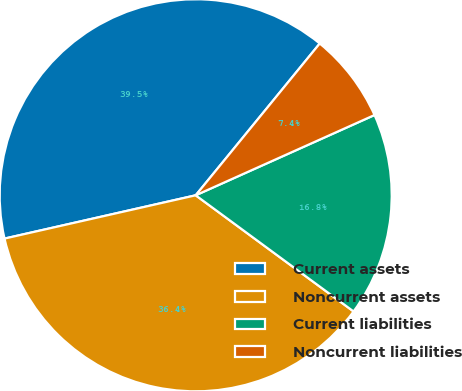Convert chart. <chart><loc_0><loc_0><loc_500><loc_500><pie_chart><fcel>Current assets<fcel>Noncurrent assets<fcel>Current liabilities<fcel>Noncurrent liabilities<nl><fcel>39.45%<fcel>36.36%<fcel>16.81%<fcel>7.38%<nl></chart> 